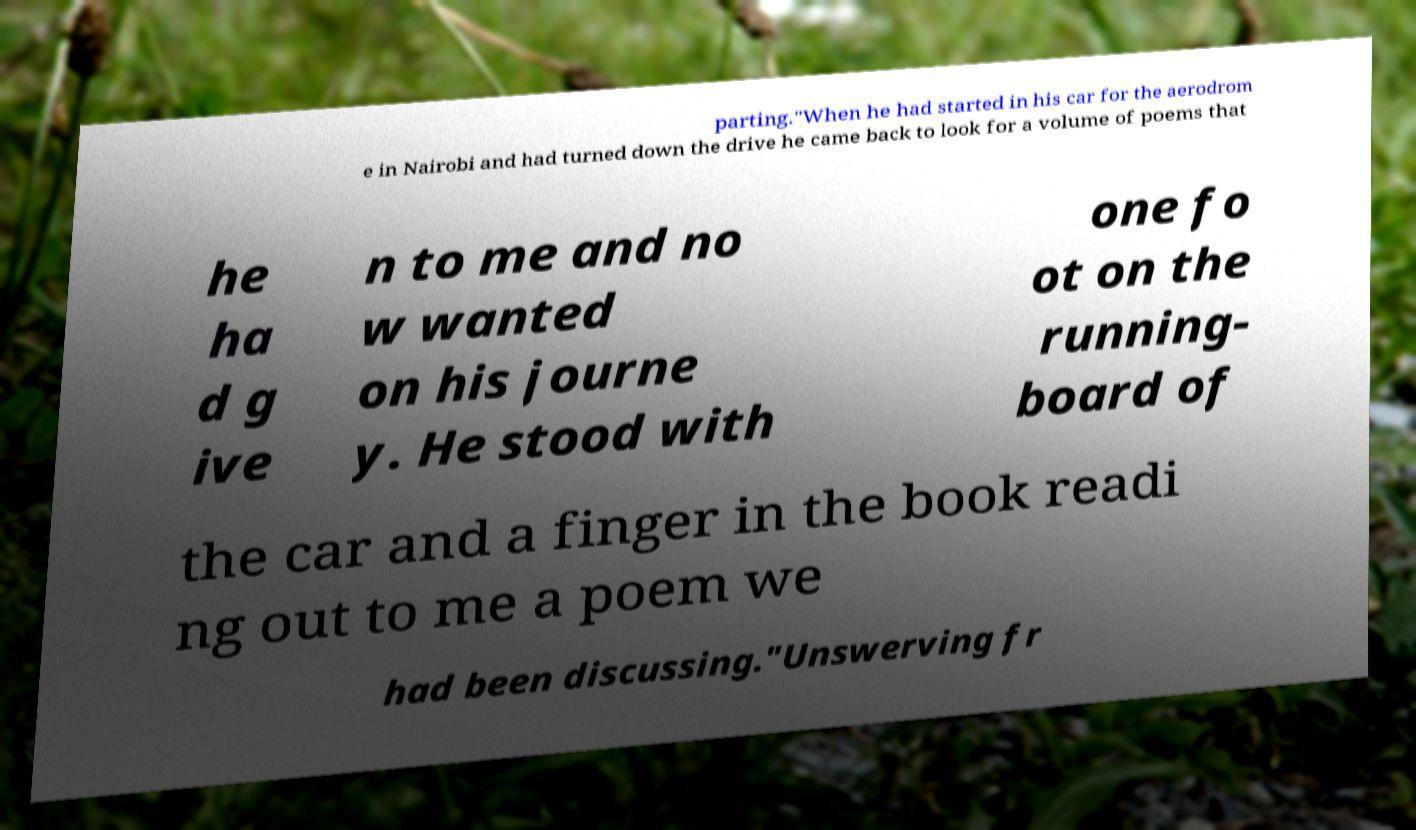There's text embedded in this image that I need extracted. Can you transcribe it verbatim? parting."When he had started in his car for the aerodrom e in Nairobi and had turned down the drive he came back to look for a volume of poems that he ha d g ive n to me and no w wanted on his journe y. He stood with one fo ot on the running- board of the car and a finger in the book readi ng out to me a poem we had been discussing."Unswerving fr 